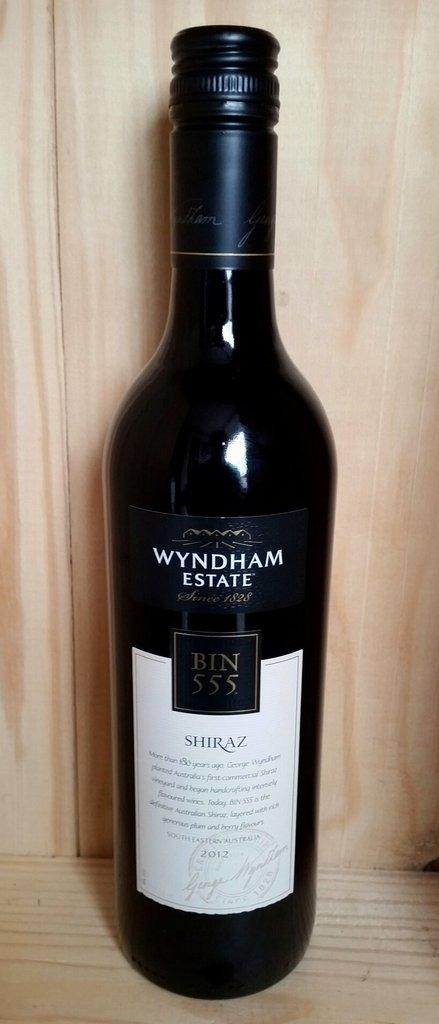<image>
Offer a succinct explanation of the picture presented. A bottle of Wyndham Estate shiraz has a screw top. 